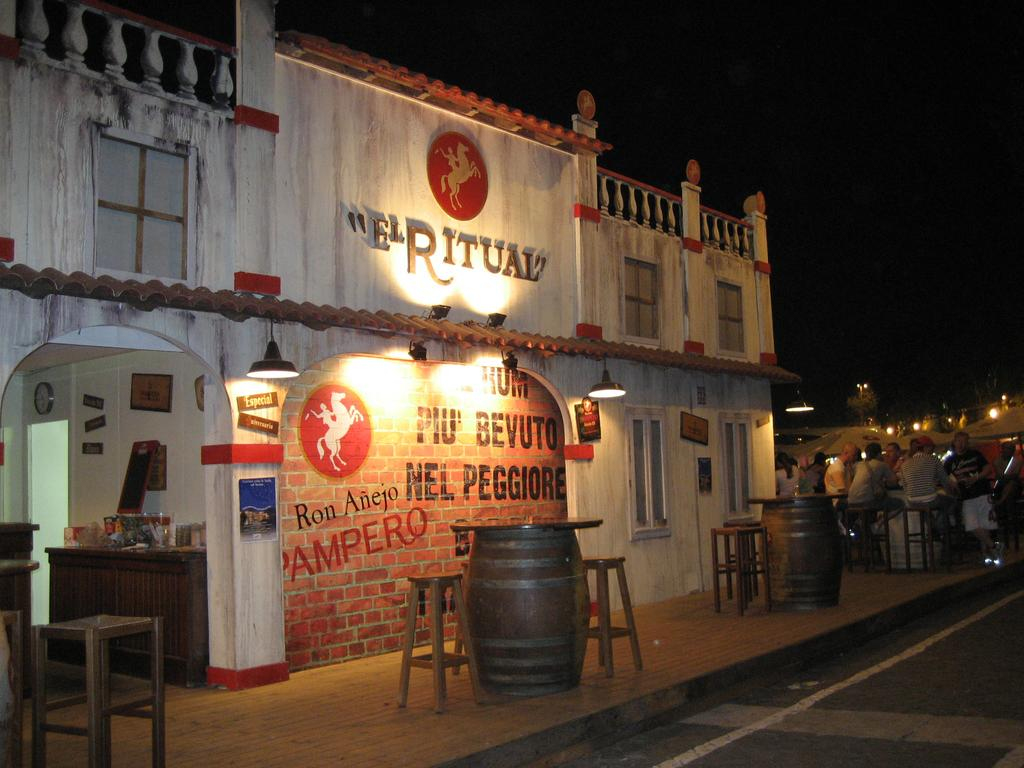<image>
Write a terse but informative summary of the picture. The outside of a restaurant called "El Ritual" has barrels and stools in front of it. 